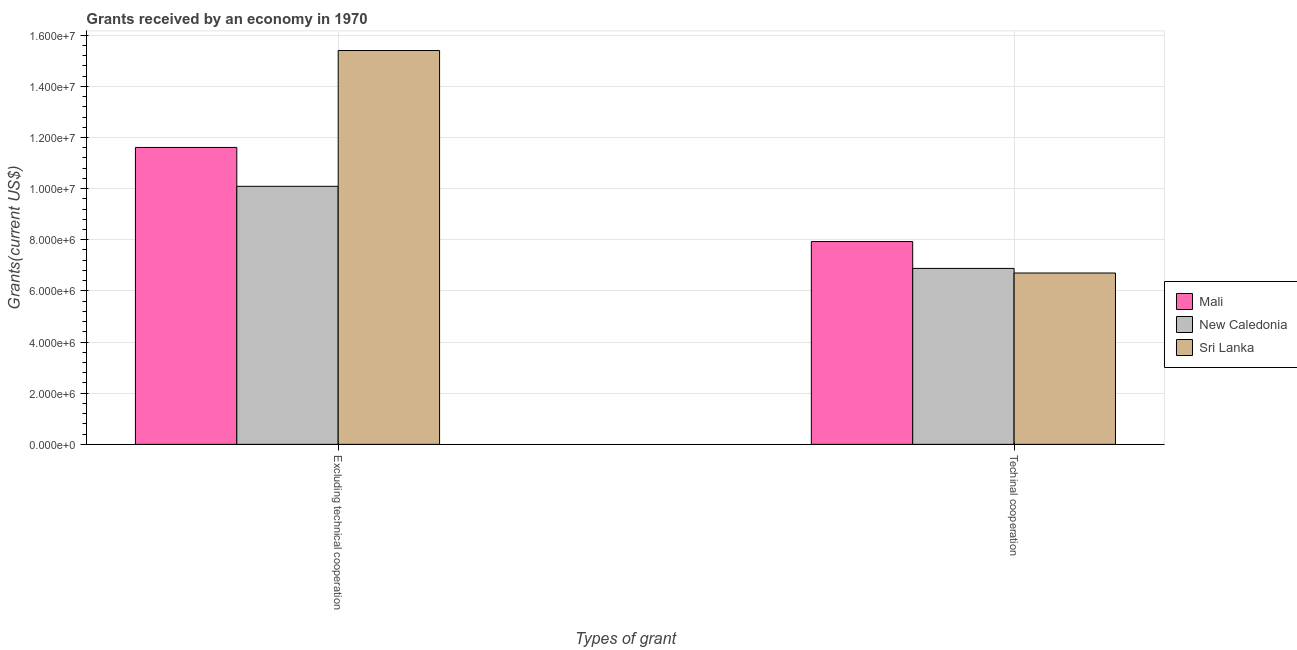How many groups of bars are there?
Give a very brief answer. 2. Are the number of bars per tick equal to the number of legend labels?
Offer a very short reply. Yes. How many bars are there on the 2nd tick from the right?
Offer a terse response. 3. What is the label of the 1st group of bars from the left?
Give a very brief answer. Excluding technical cooperation. What is the amount of grants received(excluding technical cooperation) in New Caledonia?
Keep it short and to the point. 1.01e+07. Across all countries, what is the maximum amount of grants received(excluding technical cooperation)?
Provide a succinct answer. 1.54e+07. Across all countries, what is the minimum amount of grants received(excluding technical cooperation)?
Ensure brevity in your answer.  1.01e+07. In which country was the amount of grants received(including technical cooperation) maximum?
Ensure brevity in your answer.  Mali. In which country was the amount of grants received(including technical cooperation) minimum?
Offer a terse response. Sri Lanka. What is the total amount of grants received(including technical cooperation) in the graph?
Your response must be concise. 2.15e+07. What is the difference between the amount of grants received(excluding technical cooperation) in New Caledonia and that in Sri Lanka?
Your answer should be compact. -5.31e+06. What is the difference between the amount of grants received(including technical cooperation) in Sri Lanka and the amount of grants received(excluding technical cooperation) in Mali?
Offer a terse response. -4.91e+06. What is the average amount of grants received(excluding technical cooperation) per country?
Offer a terse response. 1.24e+07. What is the difference between the amount of grants received(excluding technical cooperation) and amount of grants received(including technical cooperation) in Sri Lanka?
Offer a very short reply. 8.70e+06. In how many countries, is the amount of grants received(including technical cooperation) greater than 5200000 US$?
Your answer should be compact. 3. What is the ratio of the amount of grants received(including technical cooperation) in Mali to that in Sri Lanka?
Provide a short and direct response. 1.18. Is the amount of grants received(including technical cooperation) in Sri Lanka less than that in New Caledonia?
Provide a succinct answer. Yes. In how many countries, is the amount of grants received(including technical cooperation) greater than the average amount of grants received(including technical cooperation) taken over all countries?
Give a very brief answer. 1. What does the 2nd bar from the left in Techinal cooperation represents?
Keep it short and to the point. New Caledonia. What does the 1st bar from the right in Techinal cooperation represents?
Offer a terse response. Sri Lanka. How many bars are there?
Offer a very short reply. 6. Are the values on the major ticks of Y-axis written in scientific E-notation?
Your answer should be compact. Yes. Does the graph contain grids?
Your answer should be compact. Yes. Where does the legend appear in the graph?
Offer a very short reply. Center right. How are the legend labels stacked?
Give a very brief answer. Vertical. What is the title of the graph?
Offer a terse response. Grants received by an economy in 1970. What is the label or title of the X-axis?
Offer a very short reply. Types of grant. What is the label or title of the Y-axis?
Offer a terse response. Grants(current US$). What is the Grants(current US$) in Mali in Excluding technical cooperation?
Keep it short and to the point. 1.16e+07. What is the Grants(current US$) of New Caledonia in Excluding technical cooperation?
Make the answer very short. 1.01e+07. What is the Grants(current US$) of Sri Lanka in Excluding technical cooperation?
Your answer should be very brief. 1.54e+07. What is the Grants(current US$) in Mali in Techinal cooperation?
Give a very brief answer. 7.93e+06. What is the Grants(current US$) of New Caledonia in Techinal cooperation?
Your answer should be compact. 6.88e+06. What is the Grants(current US$) of Sri Lanka in Techinal cooperation?
Provide a succinct answer. 6.70e+06. Across all Types of grant, what is the maximum Grants(current US$) in Mali?
Make the answer very short. 1.16e+07. Across all Types of grant, what is the maximum Grants(current US$) in New Caledonia?
Offer a very short reply. 1.01e+07. Across all Types of grant, what is the maximum Grants(current US$) in Sri Lanka?
Provide a short and direct response. 1.54e+07. Across all Types of grant, what is the minimum Grants(current US$) in Mali?
Your answer should be very brief. 7.93e+06. Across all Types of grant, what is the minimum Grants(current US$) in New Caledonia?
Your answer should be very brief. 6.88e+06. Across all Types of grant, what is the minimum Grants(current US$) of Sri Lanka?
Make the answer very short. 6.70e+06. What is the total Grants(current US$) of Mali in the graph?
Offer a very short reply. 1.95e+07. What is the total Grants(current US$) of New Caledonia in the graph?
Offer a terse response. 1.70e+07. What is the total Grants(current US$) in Sri Lanka in the graph?
Give a very brief answer. 2.21e+07. What is the difference between the Grants(current US$) in Mali in Excluding technical cooperation and that in Techinal cooperation?
Your answer should be very brief. 3.68e+06. What is the difference between the Grants(current US$) of New Caledonia in Excluding technical cooperation and that in Techinal cooperation?
Offer a very short reply. 3.21e+06. What is the difference between the Grants(current US$) in Sri Lanka in Excluding technical cooperation and that in Techinal cooperation?
Provide a short and direct response. 8.70e+06. What is the difference between the Grants(current US$) of Mali in Excluding technical cooperation and the Grants(current US$) of New Caledonia in Techinal cooperation?
Provide a short and direct response. 4.73e+06. What is the difference between the Grants(current US$) of Mali in Excluding technical cooperation and the Grants(current US$) of Sri Lanka in Techinal cooperation?
Give a very brief answer. 4.91e+06. What is the difference between the Grants(current US$) in New Caledonia in Excluding technical cooperation and the Grants(current US$) in Sri Lanka in Techinal cooperation?
Ensure brevity in your answer.  3.39e+06. What is the average Grants(current US$) of Mali per Types of grant?
Your response must be concise. 9.77e+06. What is the average Grants(current US$) of New Caledonia per Types of grant?
Provide a short and direct response. 8.48e+06. What is the average Grants(current US$) of Sri Lanka per Types of grant?
Ensure brevity in your answer.  1.10e+07. What is the difference between the Grants(current US$) of Mali and Grants(current US$) of New Caledonia in Excluding technical cooperation?
Make the answer very short. 1.52e+06. What is the difference between the Grants(current US$) in Mali and Grants(current US$) in Sri Lanka in Excluding technical cooperation?
Give a very brief answer. -3.79e+06. What is the difference between the Grants(current US$) in New Caledonia and Grants(current US$) in Sri Lanka in Excluding technical cooperation?
Provide a succinct answer. -5.31e+06. What is the difference between the Grants(current US$) in Mali and Grants(current US$) in New Caledonia in Techinal cooperation?
Offer a very short reply. 1.05e+06. What is the difference between the Grants(current US$) in Mali and Grants(current US$) in Sri Lanka in Techinal cooperation?
Keep it short and to the point. 1.23e+06. What is the ratio of the Grants(current US$) of Mali in Excluding technical cooperation to that in Techinal cooperation?
Your answer should be compact. 1.46. What is the ratio of the Grants(current US$) in New Caledonia in Excluding technical cooperation to that in Techinal cooperation?
Offer a terse response. 1.47. What is the ratio of the Grants(current US$) of Sri Lanka in Excluding technical cooperation to that in Techinal cooperation?
Your answer should be very brief. 2.3. What is the difference between the highest and the second highest Grants(current US$) of Mali?
Provide a succinct answer. 3.68e+06. What is the difference between the highest and the second highest Grants(current US$) in New Caledonia?
Your answer should be very brief. 3.21e+06. What is the difference between the highest and the second highest Grants(current US$) in Sri Lanka?
Offer a terse response. 8.70e+06. What is the difference between the highest and the lowest Grants(current US$) of Mali?
Your answer should be very brief. 3.68e+06. What is the difference between the highest and the lowest Grants(current US$) of New Caledonia?
Your answer should be compact. 3.21e+06. What is the difference between the highest and the lowest Grants(current US$) in Sri Lanka?
Keep it short and to the point. 8.70e+06. 